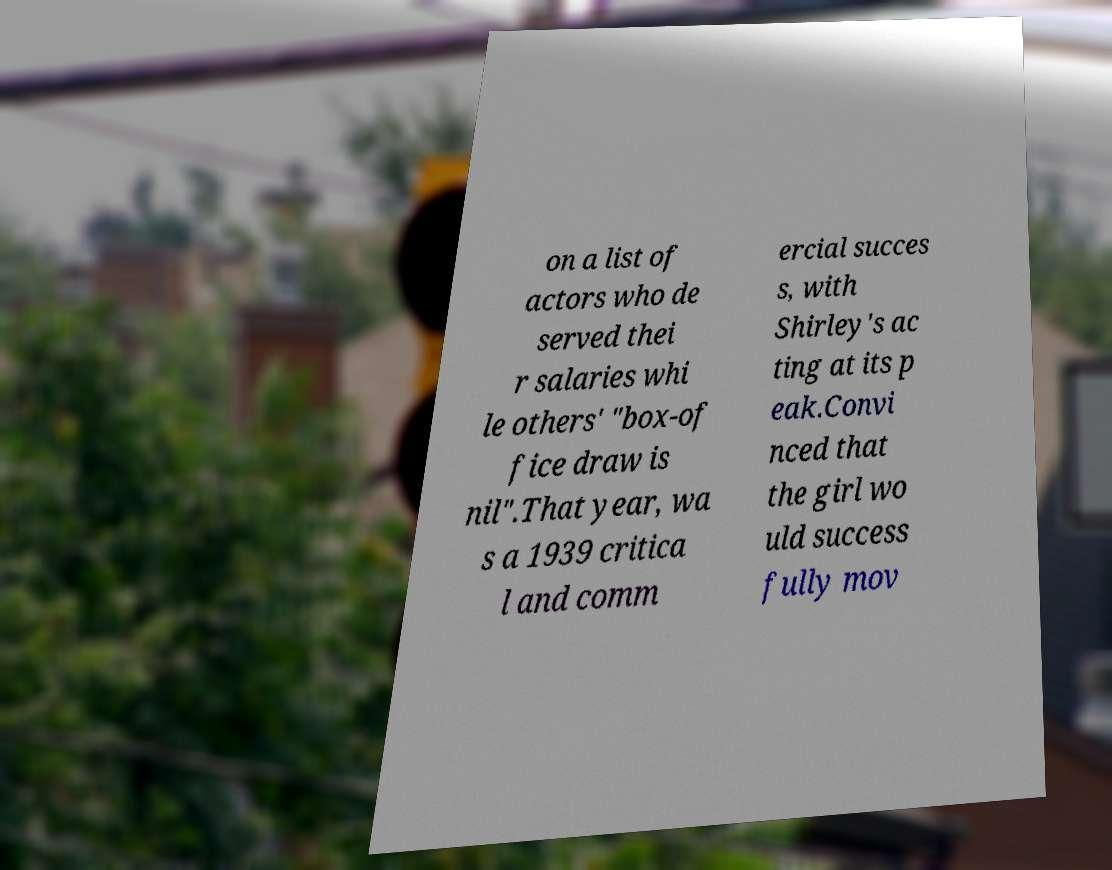Can you accurately transcribe the text from the provided image for me? on a list of actors who de served thei r salaries whi le others' "box-of fice draw is nil".That year, wa s a 1939 critica l and comm ercial succes s, with Shirley's ac ting at its p eak.Convi nced that the girl wo uld success fully mov 